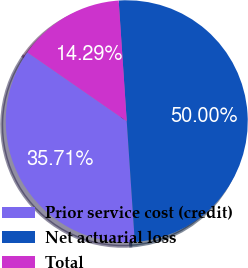<chart> <loc_0><loc_0><loc_500><loc_500><pie_chart><fcel>Prior service cost (credit)<fcel>Net actuarial loss<fcel>Total<nl><fcel>35.71%<fcel>50.0%<fcel>14.29%<nl></chart> 